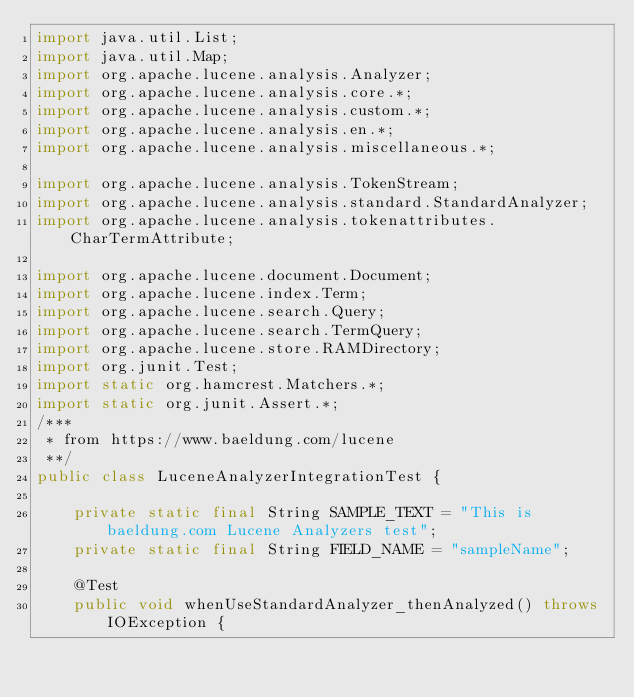<code> <loc_0><loc_0><loc_500><loc_500><_Java_>import java.util.List;
import java.util.Map;
import org.apache.lucene.analysis.Analyzer;
import org.apache.lucene.analysis.core.*;
import org.apache.lucene.analysis.custom.*;
import org.apache.lucene.analysis.en.*;
import org.apache.lucene.analysis.miscellaneous.*;

import org.apache.lucene.analysis.TokenStream;
import org.apache.lucene.analysis.standard.StandardAnalyzer;
import org.apache.lucene.analysis.tokenattributes.CharTermAttribute;

import org.apache.lucene.document.Document;
import org.apache.lucene.index.Term;
import org.apache.lucene.search.Query;
import org.apache.lucene.search.TermQuery;
import org.apache.lucene.store.RAMDirectory;
import org.junit.Test;
import static org.hamcrest.Matchers.*;
import static org.junit.Assert.*;
/***
 * from https://www.baeldung.com/lucene
 **/
public class LuceneAnalyzerIntegrationTest {

    private static final String SAMPLE_TEXT = "This is baeldung.com Lucene Analyzers test";
    private static final String FIELD_NAME = "sampleName";

    @Test
    public void whenUseStandardAnalyzer_thenAnalyzed() throws IOException {</code> 